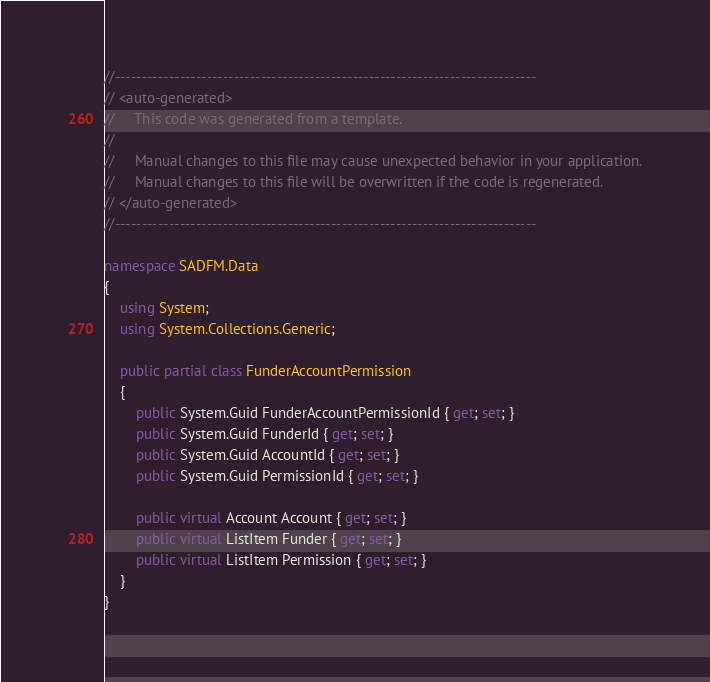Convert code to text. <code><loc_0><loc_0><loc_500><loc_500><_C#_>//------------------------------------------------------------------------------
// <auto-generated>
//     This code was generated from a template.
//
//     Manual changes to this file may cause unexpected behavior in your application.
//     Manual changes to this file will be overwritten if the code is regenerated.
// </auto-generated>
//------------------------------------------------------------------------------

namespace SADFM.Data
{
    using System;
    using System.Collections.Generic;
    
    public partial class FunderAccountPermission
    {
        public System.Guid FunderAccountPermissionId { get; set; }
        public System.Guid FunderId { get; set; }
        public System.Guid AccountId { get; set; }
        public System.Guid PermissionId { get; set; }
    
        public virtual Account Account { get; set; }
        public virtual ListItem Funder { get; set; }
        public virtual ListItem Permission { get; set; }
    }
}
</code> 